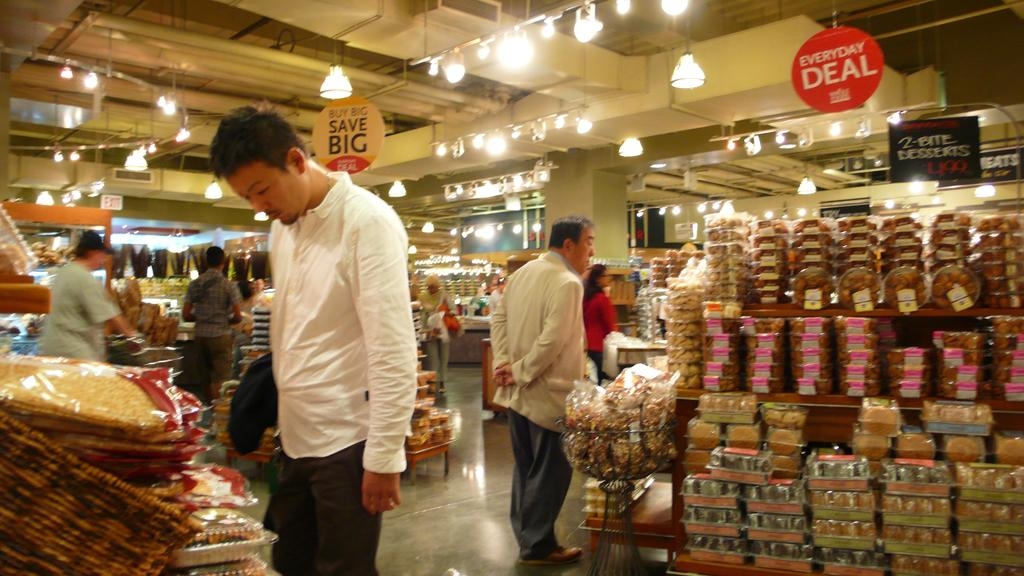<image>
Create a compact narrative representing the image presented. A store has hanging signs that state everyday deals and save big. 